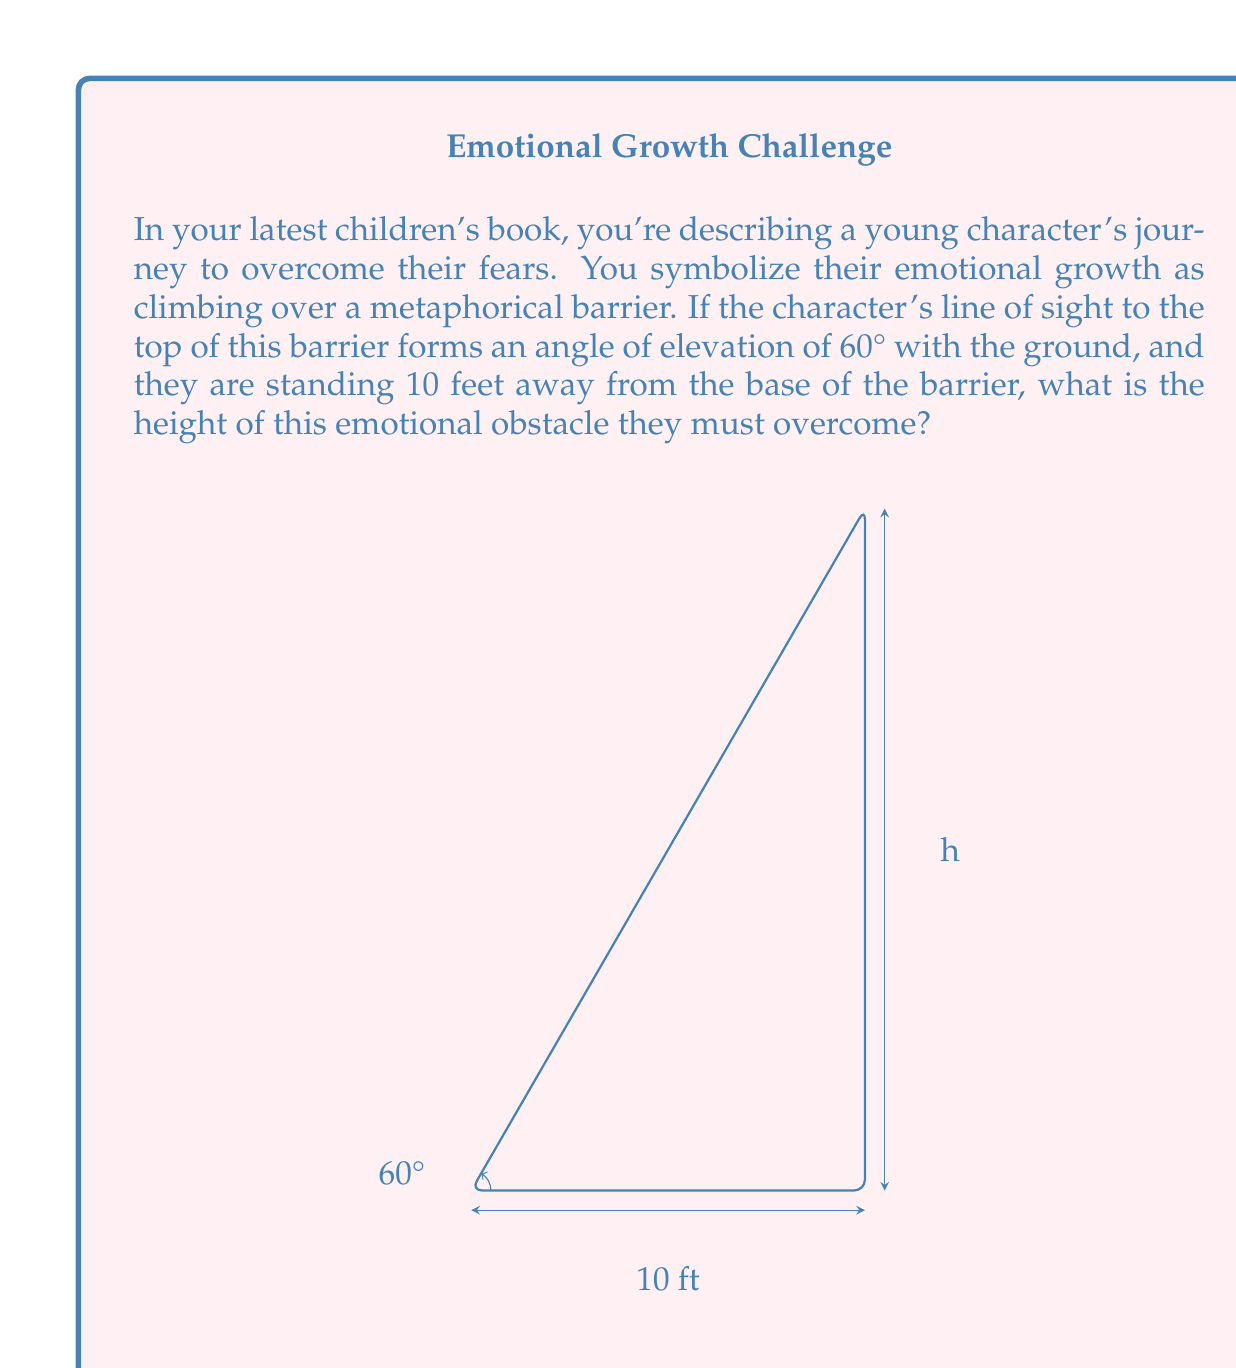Show me your answer to this math problem. Let's approach this step-by-step using trigonometry:

1) In this problem, we have a right triangle where:
   - The adjacent side is the distance from the character to the base of the barrier (10 feet)
   - The opposite side is the height of the barrier (what we're solving for)
   - The angle of elevation is 60°

2) We can use the tangent function to solve for the height. The tangent of an angle in a right triangle is the ratio of the opposite side to the adjacent side.

3) Let's call the height $h$. We can write the equation:

   $$\tan(60°) = \frac{h}{10}$$

4) We know that $\tan(60°) = \sqrt{3}$, so we can rewrite our equation:

   $$\sqrt{3} = \frac{h}{10}$$

5) To solve for $h$, multiply both sides by 10:

   $$10\sqrt{3} = h$$

6) Simplify:

   $$h = 10\sqrt{3} \approx 17.32$$

Thus, the height of the emotional barrier is $10\sqrt{3}$ feet, or approximately 17.32 feet.
Answer: $10\sqrt{3}$ feet or approximately 17.32 feet 